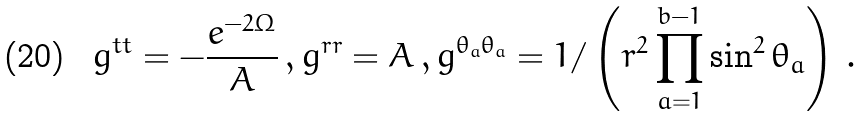Convert formula to latex. <formula><loc_0><loc_0><loc_500><loc_500>g ^ { t t } = - \frac { e ^ { - 2 \Omega } } { A } \, , g ^ { r r } = A \, , g ^ { \theta _ { a } \theta _ { a } } = 1 / \left ( r ^ { 2 } \prod _ { a = 1 } ^ { b - 1 } \sin ^ { 2 } \theta _ { a } \right ) \, .</formula> 